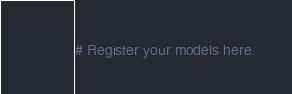Convert code to text. <code><loc_0><loc_0><loc_500><loc_500><_Python_>
# Register your models here.
</code> 